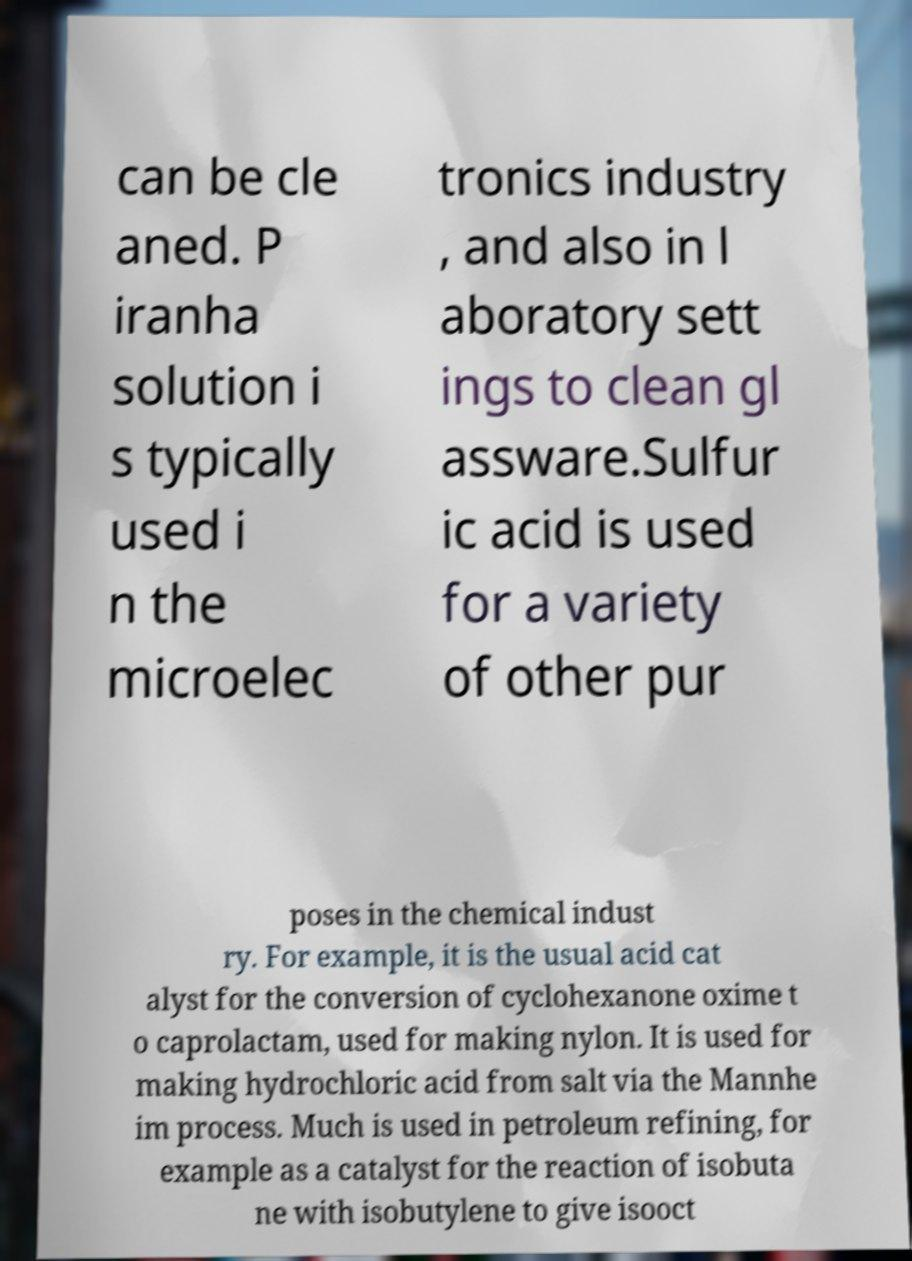Can you accurately transcribe the text from the provided image for me? can be cle aned. P iranha solution i s typically used i n the microelec tronics industry , and also in l aboratory sett ings to clean gl assware.Sulfur ic acid is used for a variety of other pur poses in the chemical indust ry. For example, it is the usual acid cat alyst for the conversion of cyclohexanone oxime t o caprolactam, used for making nylon. It is used for making hydrochloric acid from salt via the Mannhe im process. Much is used in petroleum refining, for example as a catalyst for the reaction of isobuta ne with isobutylene to give isooct 